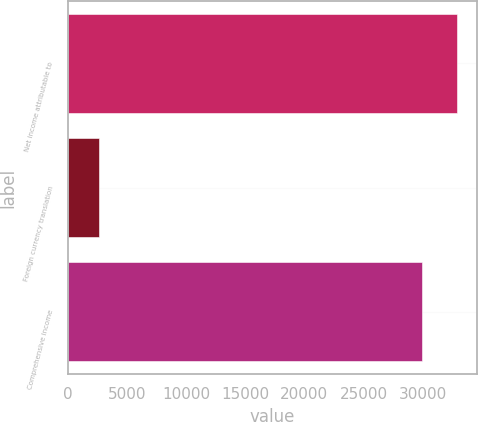<chart> <loc_0><loc_0><loc_500><loc_500><bar_chart><fcel>Net income attributable to<fcel>Foreign currency translation<fcel>Comprehensive income<nl><fcel>32909.8<fcel>2696<fcel>29918<nl></chart> 